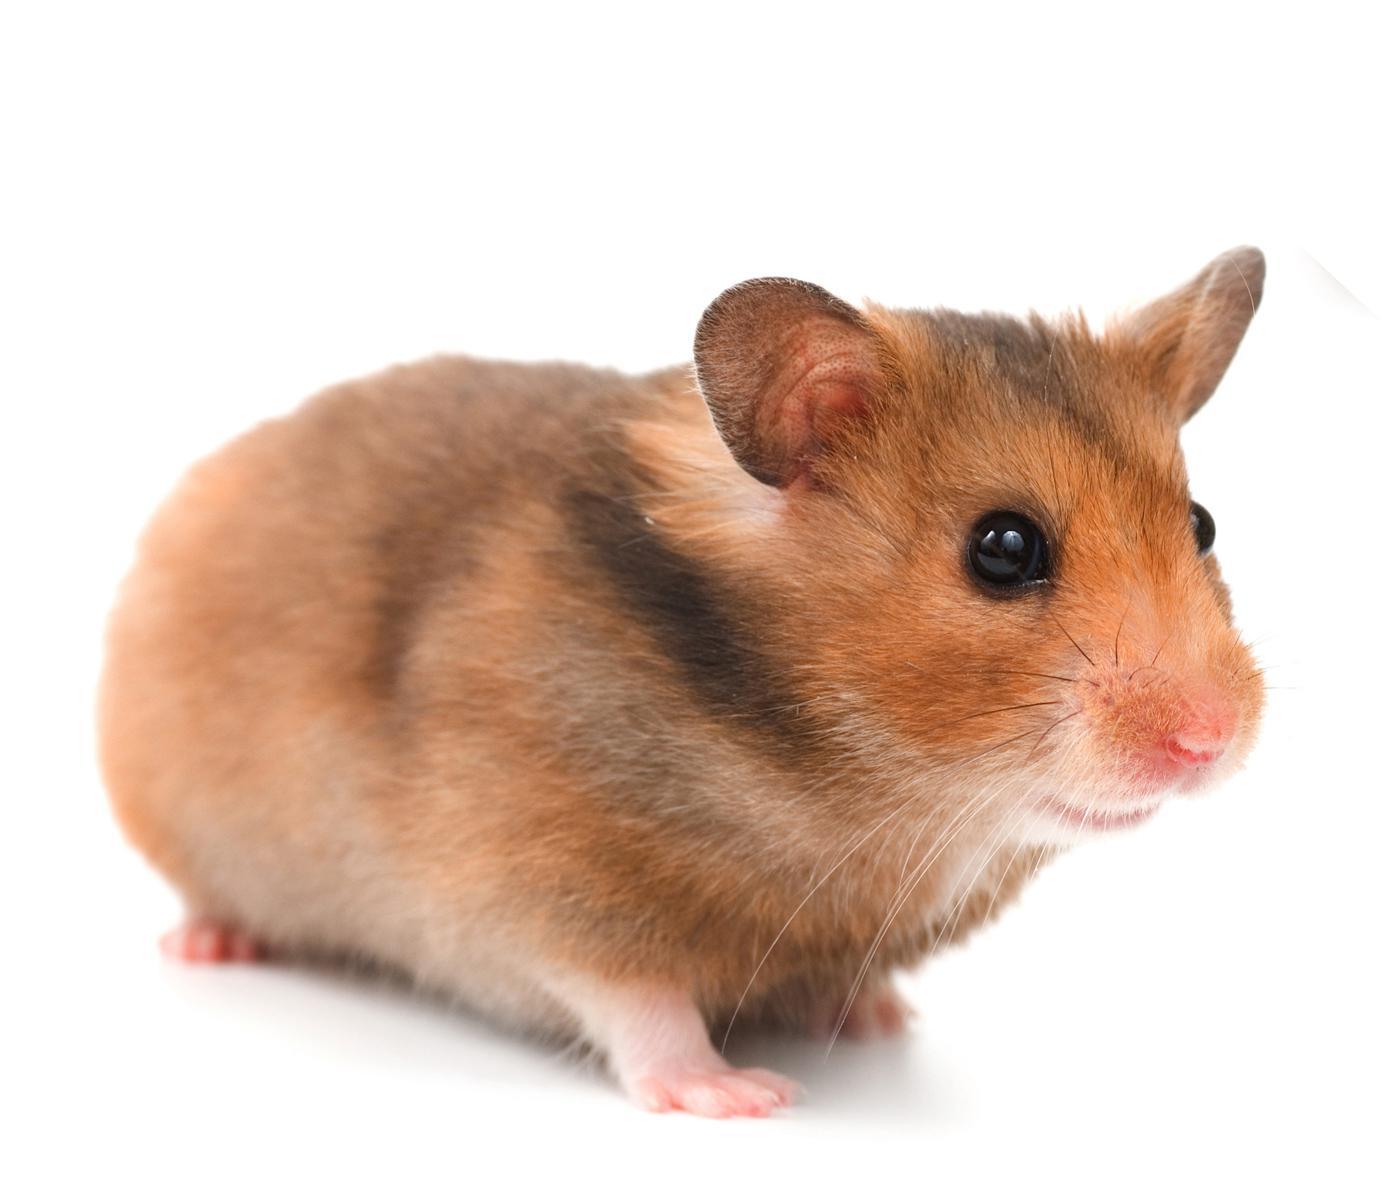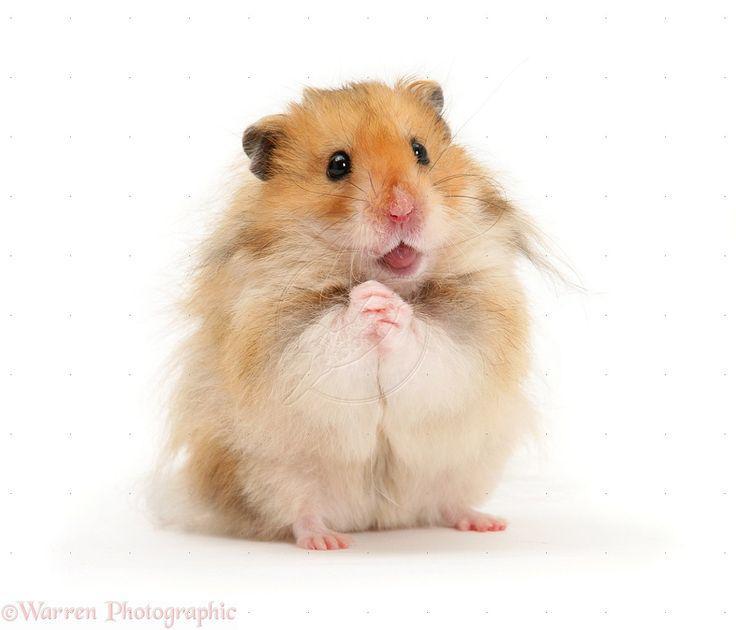The first image is the image on the left, the second image is the image on the right. Assess this claim about the two images: "Food sits on the surface in front of a rodent in one of the images.". Correct or not? Answer yes or no. No. The first image is the image on the left, the second image is the image on the right. Analyze the images presented: Is the assertion "An edible item is to the left of a small rodent in one image." valid? Answer yes or no. No. 